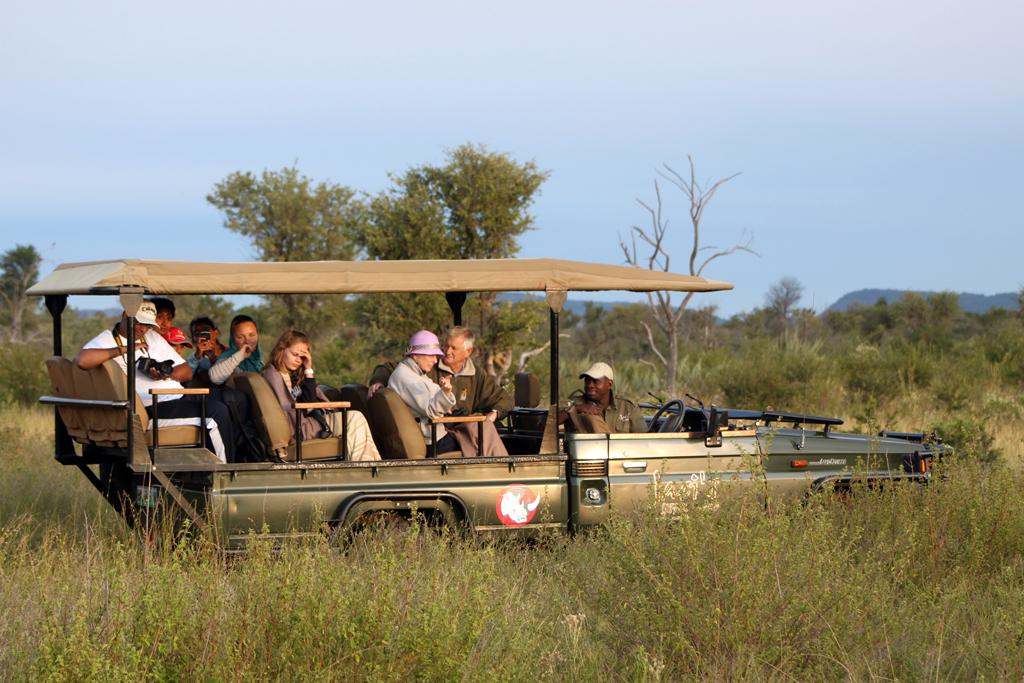What are the people in the image doing? The people in the image are sitting in a vehicle. Who is holding a camera in the image? A person is holding a camera in the image. What can be seen in the background of the image? There are trees, plants, mountains, and the sky visible in the background. What type of flag is being waved by the beggar in the image? There is no beggar or flag present in the image. 